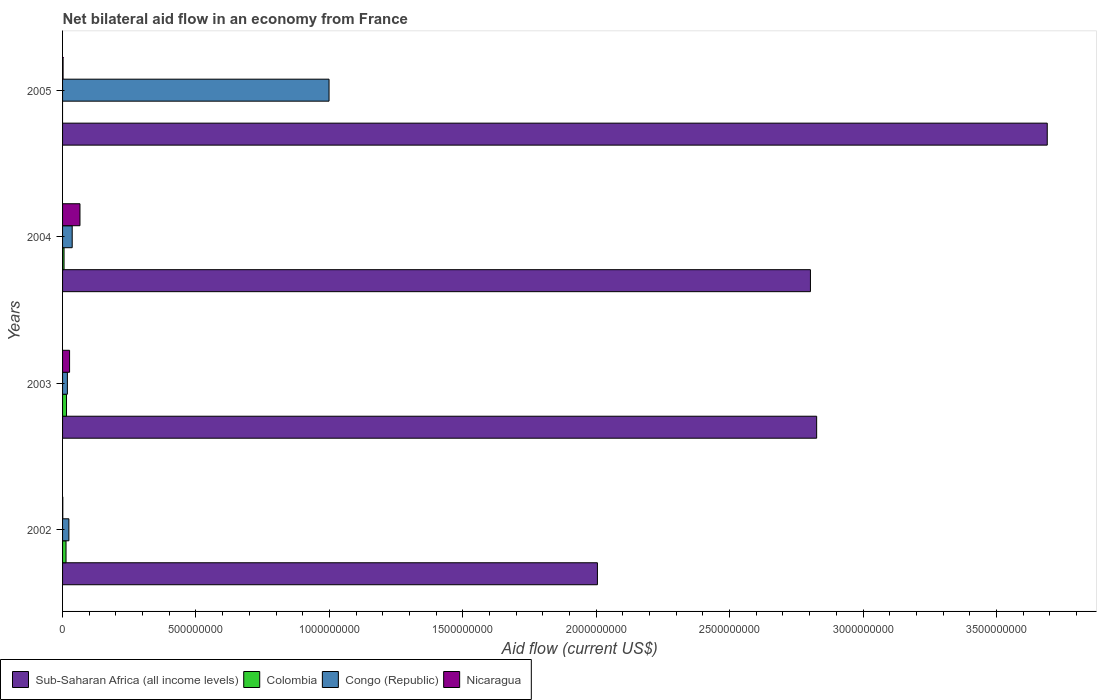How many different coloured bars are there?
Provide a short and direct response. 4. How many groups of bars are there?
Offer a terse response. 4. Are the number of bars on each tick of the Y-axis equal?
Offer a very short reply. No. What is the label of the 1st group of bars from the top?
Ensure brevity in your answer.  2005. Across all years, what is the maximum net bilateral aid flow in Sub-Saharan Africa (all income levels)?
Your answer should be very brief. 3.69e+09. Across all years, what is the minimum net bilateral aid flow in Congo (Republic)?
Provide a succinct answer. 1.81e+07. In which year was the net bilateral aid flow in Congo (Republic) maximum?
Your answer should be very brief. 2005. What is the total net bilateral aid flow in Colombia in the graph?
Ensure brevity in your answer.  3.33e+07. What is the difference between the net bilateral aid flow in Nicaragua in 2002 and that in 2003?
Provide a succinct answer. -2.54e+07. What is the difference between the net bilateral aid flow in Congo (Republic) in 2003 and the net bilateral aid flow in Colombia in 2002?
Your response must be concise. 5.10e+06. What is the average net bilateral aid flow in Nicaragua per year?
Your answer should be compact. 2.36e+07. In the year 2002, what is the difference between the net bilateral aid flow in Colombia and net bilateral aid flow in Sub-Saharan Africa (all income levels)?
Offer a very short reply. -1.99e+09. What is the ratio of the net bilateral aid flow in Congo (Republic) in 2003 to that in 2004?
Your response must be concise. 0.5. Is the difference between the net bilateral aid flow in Colombia in 2003 and 2004 greater than the difference between the net bilateral aid flow in Sub-Saharan Africa (all income levels) in 2003 and 2004?
Make the answer very short. No. What is the difference between the highest and the second highest net bilateral aid flow in Nicaragua?
Your answer should be very brief. 3.90e+07. What is the difference between the highest and the lowest net bilateral aid flow in Congo (Republic)?
Offer a very short reply. 9.81e+08. Is it the case that in every year, the sum of the net bilateral aid flow in Congo (Republic) and net bilateral aid flow in Sub-Saharan Africa (all income levels) is greater than the net bilateral aid flow in Colombia?
Give a very brief answer. Yes. How many years are there in the graph?
Give a very brief answer. 4. Are the values on the major ticks of X-axis written in scientific E-notation?
Keep it short and to the point. No. Does the graph contain grids?
Ensure brevity in your answer.  No. Where does the legend appear in the graph?
Provide a short and direct response. Bottom left. How many legend labels are there?
Your answer should be compact. 4. What is the title of the graph?
Ensure brevity in your answer.  Net bilateral aid flow in an economy from France. What is the label or title of the X-axis?
Offer a terse response. Aid flow (current US$). What is the Aid flow (current US$) in Sub-Saharan Africa (all income levels) in 2002?
Keep it short and to the point. 2.00e+09. What is the Aid flow (current US$) of Colombia in 2002?
Your answer should be compact. 1.30e+07. What is the Aid flow (current US$) in Congo (Republic) in 2002?
Keep it short and to the point. 2.37e+07. What is the Aid flow (current US$) of Nicaragua in 2002?
Make the answer very short. 8.80e+05. What is the Aid flow (current US$) in Sub-Saharan Africa (all income levels) in 2003?
Make the answer very short. 2.83e+09. What is the Aid flow (current US$) of Colombia in 2003?
Ensure brevity in your answer.  1.48e+07. What is the Aid flow (current US$) in Congo (Republic) in 2003?
Your response must be concise. 1.81e+07. What is the Aid flow (current US$) of Nicaragua in 2003?
Make the answer very short. 2.63e+07. What is the Aid flow (current US$) of Sub-Saharan Africa (all income levels) in 2004?
Provide a short and direct response. 2.80e+09. What is the Aid flow (current US$) of Colombia in 2004?
Offer a terse response. 5.57e+06. What is the Aid flow (current US$) in Congo (Republic) in 2004?
Keep it short and to the point. 3.61e+07. What is the Aid flow (current US$) in Nicaragua in 2004?
Ensure brevity in your answer.  6.52e+07. What is the Aid flow (current US$) in Sub-Saharan Africa (all income levels) in 2005?
Provide a succinct answer. 3.69e+09. What is the Aid flow (current US$) in Congo (Republic) in 2005?
Provide a short and direct response. 9.99e+08. What is the Aid flow (current US$) in Nicaragua in 2005?
Offer a terse response. 1.93e+06. Across all years, what is the maximum Aid flow (current US$) of Sub-Saharan Africa (all income levels)?
Offer a terse response. 3.69e+09. Across all years, what is the maximum Aid flow (current US$) in Colombia?
Your answer should be compact. 1.48e+07. Across all years, what is the maximum Aid flow (current US$) of Congo (Republic)?
Offer a very short reply. 9.99e+08. Across all years, what is the maximum Aid flow (current US$) of Nicaragua?
Provide a succinct answer. 6.52e+07. Across all years, what is the minimum Aid flow (current US$) of Sub-Saharan Africa (all income levels)?
Provide a short and direct response. 2.00e+09. Across all years, what is the minimum Aid flow (current US$) in Colombia?
Provide a short and direct response. 0. Across all years, what is the minimum Aid flow (current US$) of Congo (Republic)?
Keep it short and to the point. 1.81e+07. Across all years, what is the minimum Aid flow (current US$) in Nicaragua?
Your answer should be compact. 8.80e+05. What is the total Aid flow (current US$) of Sub-Saharan Africa (all income levels) in the graph?
Provide a short and direct response. 1.13e+1. What is the total Aid flow (current US$) of Colombia in the graph?
Provide a short and direct response. 3.33e+07. What is the total Aid flow (current US$) of Congo (Republic) in the graph?
Give a very brief answer. 1.08e+09. What is the total Aid flow (current US$) of Nicaragua in the graph?
Offer a very short reply. 9.43e+07. What is the difference between the Aid flow (current US$) in Sub-Saharan Africa (all income levels) in 2002 and that in 2003?
Your response must be concise. -8.22e+08. What is the difference between the Aid flow (current US$) of Colombia in 2002 and that in 2003?
Your answer should be very brief. -1.81e+06. What is the difference between the Aid flow (current US$) of Congo (Republic) in 2002 and that in 2003?
Provide a succinct answer. 5.65e+06. What is the difference between the Aid flow (current US$) of Nicaragua in 2002 and that in 2003?
Provide a short and direct response. -2.54e+07. What is the difference between the Aid flow (current US$) in Sub-Saharan Africa (all income levels) in 2002 and that in 2004?
Your response must be concise. -7.98e+08. What is the difference between the Aid flow (current US$) in Colombia in 2002 and that in 2004?
Ensure brevity in your answer.  7.41e+06. What is the difference between the Aid flow (current US$) of Congo (Republic) in 2002 and that in 2004?
Offer a terse response. -1.24e+07. What is the difference between the Aid flow (current US$) of Nicaragua in 2002 and that in 2004?
Make the answer very short. -6.44e+07. What is the difference between the Aid flow (current US$) in Sub-Saharan Africa (all income levels) in 2002 and that in 2005?
Your answer should be very brief. -1.69e+09. What is the difference between the Aid flow (current US$) in Congo (Republic) in 2002 and that in 2005?
Offer a terse response. -9.75e+08. What is the difference between the Aid flow (current US$) of Nicaragua in 2002 and that in 2005?
Your response must be concise. -1.05e+06. What is the difference between the Aid flow (current US$) of Sub-Saharan Africa (all income levels) in 2003 and that in 2004?
Offer a terse response. 2.33e+07. What is the difference between the Aid flow (current US$) in Colombia in 2003 and that in 2004?
Your response must be concise. 9.22e+06. What is the difference between the Aid flow (current US$) in Congo (Republic) in 2003 and that in 2004?
Provide a succinct answer. -1.80e+07. What is the difference between the Aid flow (current US$) in Nicaragua in 2003 and that in 2004?
Make the answer very short. -3.90e+07. What is the difference between the Aid flow (current US$) of Sub-Saharan Africa (all income levels) in 2003 and that in 2005?
Your answer should be compact. -8.64e+08. What is the difference between the Aid flow (current US$) of Congo (Republic) in 2003 and that in 2005?
Your response must be concise. -9.81e+08. What is the difference between the Aid flow (current US$) of Nicaragua in 2003 and that in 2005?
Your answer should be very brief. 2.43e+07. What is the difference between the Aid flow (current US$) of Sub-Saharan Africa (all income levels) in 2004 and that in 2005?
Your answer should be very brief. -8.88e+08. What is the difference between the Aid flow (current US$) of Congo (Republic) in 2004 and that in 2005?
Keep it short and to the point. -9.63e+08. What is the difference between the Aid flow (current US$) of Nicaragua in 2004 and that in 2005?
Your response must be concise. 6.33e+07. What is the difference between the Aid flow (current US$) in Sub-Saharan Africa (all income levels) in 2002 and the Aid flow (current US$) in Colombia in 2003?
Offer a very short reply. 1.99e+09. What is the difference between the Aid flow (current US$) in Sub-Saharan Africa (all income levels) in 2002 and the Aid flow (current US$) in Congo (Republic) in 2003?
Your answer should be compact. 1.99e+09. What is the difference between the Aid flow (current US$) of Sub-Saharan Africa (all income levels) in 2002 and the Aid flow (current US$) of Nicaragua in 2003?
Make the answer very short. 1.98e+09. What is the difference between the Aid flow (current US$) in Colombia in 2002 and the Aid flow (current US$) in Congo (Republic) in 2003?
Provide a short and direct response. -5.10e+06. What is the difference between the Aid flow (current US$) in Colombia in 2002 and the Aid flow (current US$) in Nicaragua in 2003?
Your response must be concise. -1.33e+07. What is the difference between the Aid flow (current US$) in Congo (Republic) in 2002 and the Aid flow (current US$) in Nicaragua in 2003?
Give a very brief answer. -2.54e+06. What is the difference between the Aid flow (current US$) of Sub-Saharan Africa (all income levels) in 2002 and the Aid flow (current US$) of Colombia in 2004?
Your response must be concise. 2.00e+09. What is the difference between the Aid flow (current US$) of Sub-Saharan Africa (all income levels) in 2002 and the Aid flow (current US$) of Congo (Republic) in 2004?
Your answer should be compact. 1.97e+09. What is the difference between the Aid flow (current US$) in Sub-Saharan Africa (all income levels) in 2002 and the Aid flow (current US$) in Nicaragua in 2004?
Provide a succinct answer. 1.94e+09. What is the difference between the Aid flow (current US$) in Colombia in 2002 and the Aid flow (current US$) in Congo (Republic) in 2004?
Your answer should be compact. -2.31e+07. What is the difference between the Aid flow (current US$) in Colombia in 2002 and the Aid flow (current US$) in Nicaragua in 2004?
Make the answer very short. -5.23e+07. What is the difference between the Aid flow (current US$) of Congo (Republic) in 2002 and the Aid flow (current US$) of Nicaragua in 2004?
Give a very brief answer. -4.15e+07. What is the difference between the Aid flow (current US$) of Sub-Saharan Africa (all income levels) in 2002 and the Aid flow (current US$) of Congo (Republic) in 2005?
Make the answer very short. 1.01e+09. What is the difference between the Aid flow (current US$) in Sub-Saharan Africa (all income levels) in 2002 and the Aid flow (current US$) in Nicaragua in 2005?
Make the answer very short. 2.00e+09. What is the difference between the Aid flow (current US$) of Colombia in 2002 and the Aid flow (current US$) of Congo (Republic) in 2005?
Ensure brevity in your answer.  -9.86e+08. What is the difference between the Aid flow (current US$) of Colombia in 2002 and the Aid flow (current US$) of Nicaragua in 2005?
Offer a terse response. 1.10e+07. What is the difference between the Aid flow (current US$) of Congo (Republic) in 2002 and the Aid flow (current US$) of Nicaragua in 2005?
Ensure brevity in your answer.  2.18e+07. What is the difference between the Aid flow (current US$) of Sub-Saharan Africa (all income levels) in 2003 and the Aid flow (current US$) of Colombia in 2004?
Offer a terse response. 2.82e+09. What is the difference between the Aid flow (current US$) of Sub-Saharan Africa (all income levels) in 2003 and the Aid flow (current US$) of Congo (Republic) in 2004?
Make the answer very short. 2.79e+09. What is the difference between the Aid flow (current US$) of Sub-Saharan Africa (all income levels) in 2003 and the Aid flow (current US$) of Nicaragua in 2004?
Provide a short and direct response. 2.76e+09. What is the difference between the Aid flow (current US$) in Colombia in 2003 and the Aid flow (current US$) in Congo (Republic) in 2004?
Ensure brevity in your answer.  -2.13e+07. What is the difference between the Aid flow (current US$) of Colombia in 2003 and the Aid flow (current US$) of Nicaragua in 2004?
Your answer should be compact. -5.05e+07. What is the difference between the Aid flow (current US$) in Congo (Republic) in 2003 and the Aid flow (current US$) in Nicaragua in 2004?
Offer a very short reply. -4.72e+07. What is the difference between the Aid flow (current US$) in Sub-Saharan Africa (all income levels) in 2003 and the Aid flow (current US$) in Congo (Republic) in 2005?
Your response must be concise. 1.83e+09. What is the difference between the Aid flow (current US$) of Sub-Saharan Africa (all income levels) in 2003 and the Aid flow (current US$) of Nicaragua in 2005?
Your response must be concise. 2.82e+09. What is the difference between the Aid flow (current US$) of Colombia in 2003 and the Aid flow (current US$) of Congo (Republic) in 2005?
Give a very brief answer. -9.84e+08. What is the difference between the Aid flow (current US$) in Colombia in 2003 and the Aid flow (current US$) in Nicaragua in 2005?
Keep it short and to the point. 1.29e+07. What is the difference between the Aid flow (current US$) of Congo (Republic) in 2003 and the Aid flow (current US$) of Nicaragua in 2005?
Offer a very short reply. 1.62e+07. What is the difference between the Aid flow (current US$) in Sub-Saharan Africa (all income levels) in 2004 and the Aid flow (current US$) in Congo (Republic) in 2005?
Provide a succinct answer. 1.80e+09. What is the difference between the Aid flow (current US$) of Sub-Saharan Africa (all income levels) in 2004 and the Aid flow (current US$) of Nicaragua in 2005?
Provide a succinct answer. 2.80e+09. What is the difference between the Aid flow (current US$) in Colombia in 2004 and the Aid flow (current US$) in Congo (Republic) in 2005?
Your answer should be compact. -9.93e+08. What is the difference between the Aid flow (current US$) of Colombia in 2004 and the Aid flow (current US$) of Nicaragua in 2005?
Your answer should be very brief. 3.64e+06. What is the difference between the Aid flow (current US$) of Congo (Republic) in 2004 and the Aid flow (current US$) of Nicaragua in 2005?
Ensure brevity in your answer.  3.42e+07. What is the average Aid flow (current US$) in Sub-Saharan Africa (all income levels) per year?
Provide a short and direct response. 2.83e+09. What is the average Aid flow (current US$) in Colombia per year?
Your answer should be very brief. 8.34e+06. What is the average Aid flow (current US$) in Congo (Republic) per year?
Your response must be concise. 2.69e+08. What is the average Aid flow (current US$) of Nicaragua per year?
Your answer should be very brief. 2.36e+07. In the year 2002, what is the difference between the Aid flow (current US$) in Sub-Saharan Africa (all income levels) and Aid flow (current US$) in Colombia?
Ensure brevity in your answer.  1.99e+09. In the year 2002, what is the difference between the Aid flow (current US$) of Sub-Saharan Africa (all income levels) and Aid flow (current US$) of Congo (Republic)?
Give a very brief answer. 1.98e+09. In the year 2002, what is the difference between the Aid flow (current US$) of Sub-Saharan Africa (all income levels) and Aid flow (current US$) of Nicaragua?
Your answer should be compact. 2.00e+09. In the year 2002, what is the difference between the Aid flow (current US$) in Colombia and Aid flow (current US$) in Congo (Republic)?
Provide a short and direct response. -1.08e+07. In the year 2002, what is the difference between the Aid flow (current US$) of Colombia and Aid flow (current US$) of Nicaragua?
Keep it short and to the point. 1.21e+07. In the year 2002, what is the difference between the Aid flow (current US$) in Congo (Republic) and Aid flow (current US$) in Nicaragua?
Keep it short and to the point. 2.28e+07. In the year 2003, what is the difference between the Aid flow (current US$) of Sub-Saharan Africa (all income levels) and Aid flow (current US$) of Colombia?
Your answer should be compact. 2.81e+09. In the year 2003, what is the difference between the Aid flow (current US$) of Sub-Saharan Africa (all income levels) and Aid flow (current US$) of Congo (Republic)?
Keep it short and to the point. 2.81e+09. In the year 2003, what is the difference between the Aid flow (current US$) in Sub-Saharan Africa (all income levels) and Aid flow (current US$) in Nicaragua?
Ensure brevity in your answer.  2.80e+09. In the year 2003, what is the difference between the Aid flow (current US$) of Colombia and Aid flow (current US$) of Congo (Republic)?
Your response must be concise. -3.29e+06. In the year 2003, what is the difference between the Aid flow (current US$) of Colombia and Aid flow (current US$) of Nicaragua?
Provide a succinct answer. -1.15e+07. In the year 2003, what is the difference between the Aid flow (current US$) in Congo (Republic) and Aid flow (current US$) in Nicaragua?
Offer a very short reply. -8.19e+06. In the year 2004, what is the difference between the Aid flow (current US$) in Sub-Saharan Africa (all income levels) and Aid flow (current US$) in Colombia?
Ensure brevity in your answer.  2.80e+09. In the year 2004, what is the difference between the Aid flow (current US$) of Sub-Saharan Africa (all income levels) and Aid flow (current US$) of Congo (Republic)?
Your answer should be very brief. 2.77e+09. In the year 2004, what is the difference between the Aid flow (current US$) in Sub-Saharan Africa (all income levels) and Aid flow (current US$) in Nicaragua?
Ensure brevity in your answer.  2.74e+09. In the year 2004, what is the difference between the Aid flow (current US$) in Colombia and Aid flow (current US$) in Congo (Republic)?
Offer a terse response. -3.05e+07. In the year 2004, what is the difference between the Aid flow (current US$) in Colombia and Aid flow (current US$) in Nicaragua?
Give a very brief answer. -5.97e+07. In the year 2004, what is the difference between the Aid flow (current US$) of Congo (Republic) and Aid flow (current US$) of Nicaragua?
Keep it short and to the point. -2.92e+07. In the year 2005, what is the difference between the Aid flow (current US$) in Sub-Saharan Africa (all income levels) and Aid flow (current US$) in Congo (Republic)?
Offer a very short reply. 2.69e+09. In the year 2005, what is the difference between the Aid flow (current US$) of Sub-Saharan Africa (all income levels) and Aid flow (current US$) of Nicaragua?
Offer a terse response. 3.69e+09. In the year 2005, what is the difference between the Aid flow (current US$) of Congo (Republic) and Aid flow (current US$) of Nicaragua?
Give a very brief answer. 9.97e+08. What is the ratio of the Aid flow (current US$) in Sub-Saharan Africa (all income levels) in 2002 to that in 2003?
Ensure brevity in your answer.  0.71. What is the ratio of the Aid flow (current US$) in Colombia in 2002 to that in 2003?
Offer a terse response. 0.88. What is the ratio of the Aid flow (current US$) in Congo (Republic) in 2002 to that in 2003?
Your answer should be compact. 1.31. What is the ratio of the Aid flow (current US$) in Nicaragua in 2002 to that in 2003?
Give a very brief answer. 0.03. What is the ratio of the Aid flow (current US$) of Sub-Saharan Africa (all income levels) in 2002 to that in 2004?
Keep it short and to the point. 0.72. What is the ratio of the Aid flow (current US$) in Colombia in 2002 to that in 2004?
Offer a terse response. 2.33. What is the ratio of the Aid flow (current US$) in Congo (Republic) in 2002 to that in 2004?
Your answer should be compact. 0.66. What is the ratio of the Aid flow (current US$) of Nicaragua in 2002 to that in 2004?
Give a very brief answer. 0.01. What is the ratio of the Aid flow (current US$) of Sub-Saharan Africa (all income levels) in 2002 to that in 2005?
Provide a short and direct response. 0.54. What is the ratio of the Aid flow (current US$) of Congo (Republic) in 2002 to that in 2005?
Your response must be concise. 0.02. What is the ratio of the Aid flow (current US$) in Nicaragua in 2002 to that in 2005?
Your answer should be very brief. 0.46. What is the ratio of the Aid flow (current US$) of Sub-Saharan Africa (all income levels) in 2003 to that in 2004?
Make the answer very short. 1.01. What is the ratio of the Aid flow (current US$) of Colombia in 2003 to that in 2004?
Your answer should be very brief. 2.66. What is the ratio of the Aid flow (current US$) of Congo (Republic) in 2003 to that in 2004?
Offer a terse response. 0.5. What is the ratio of the Aid flow (current US$) of Nicaragua in 2003 to that in 2004?
Keep it short and to the point. 0.4. What is the ratio of the Aid flow (current US$) in Sub-Saharan Africa (all income levels) in 2003 to that in 2005?
Your answer should be compact. 0.77. What is the ratio of the Aid flow (current US$) of Congo (Republic) in 2003 to that in 2005?
Your answer should be very brief. 0.02. What is the ratio of the Aid flow (current US$) of Nicaragua in 2003 to that in 2005?
Offer a very short reply. 13.61. What is the ratio of the Aid flow (current US$) of Sub-Saharan Africa (all income levels) in 2004 to that in 2005?
Your answer should be very brief. 0.76. What is the ratio of the Aid flow (current US$) of Congo (Republic) in 2004 to that in 2005?
Provide a short and direct response. 0.04. What is the ratio of the Aid flow (current US$) in Nicaragua in 2004 to that in 2005?
Your answer should be compact. 33.81. What is the difference between the highest and the second highest Aid flow (current US$) of Sub-Saharan Africa (all income levels)?
Keep it short and to the point. 8.64e+08. What is the difference between the highest and the second highest Aid flow (current US$) of Colombia?
Make the answer very short. 1.81e+06. What is the difference between the highest and the second highest Aid flow (current US$) of Congo (Republic)?
Your response must be concise. 9.63e+08. What is the difference between the highest and the second highest Aid flow (current US$) of Nicaragua?
Your answer should be compact. 3.90e+07. What is the difference between the highest and the lowest Aid flow (current US$) in Sub-Saharan Africa (all income levels)?
Make the answer very short. 1.69e+09. What is the difference between the highest and the lowest Aid flow (current US$) in Colombia?
Provide a short and direct response. 1.48e+07. What is the difference between the highest and the lowest Aid flow (current US$) in Congo (Republic)?
Provide a succinct answer. 9.81e+08. What is the difference between the highest and the lowest Aid flow (current US$) in Nicaragua?
Your answer should be compact. 6.44e+07. 